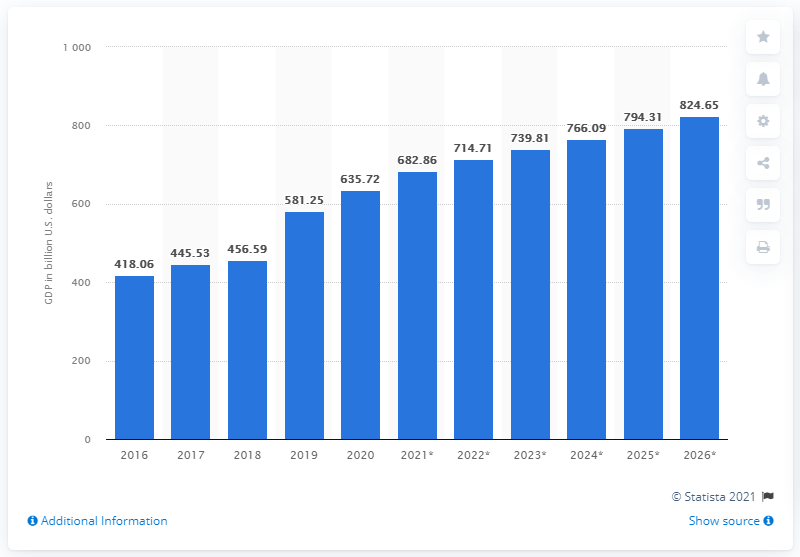Identify some key points in this picture. In 2020, Iran's GDP was approximately 635.72 billion dollars. 